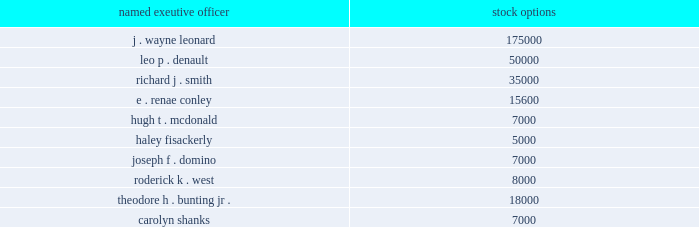For purposes of determining entergy corporation's relative performance for the 2006-2008 period , the committee used the philadelphia utility index as the peer group .
Based on market data and the recommendation of management , the committee compared entergy corporation's total shareholder return against the total shareholder return of the companies that comprised the philadelphia utility index .
Based on a comparison of entergy corporation's performance relative to the philadelphia utility index as described above , the committee concluded that entergy corporation had exceeded the performance targets for the 2006-2008 performance cycle with entergy finishing in the first quartile which resulted in a payment of 250% ( 250 % ) of target ( the maximum amount payable ) .
Each performance unit was then automatically converted into cash at the rate of $ 83.13 per unit , the closing price of entergy corporation common stock on the last trading day of the performance cycle ( december 31 , 2008 ) , plus dividend equivalents accrued over the three-year performance cycle .
See the 2008 option exercises and stock vested table for the amount paid to each of the named executive officers for the 2006-2008 performance unit cycle .
Stock options the personnel committee and in the case of the named executive officers ( other than mr .
Leonard , mr .
Denault and mr .
Smith ) , entergy's chief executive officer and the named executive officer's supervisor consider several factors in determining the amount of stock options it will grant under entergy's equity ownership plans to the named executive officers , including : individual performance ; prevailing market practice in stock option grants ; the targeted long-term value created by the use of stock options ; the number of participants eligible for stock options , and the resulting "burn rate" ( i.e. , the number of stock options authorized divided by the total number of shares outstanding ) to assess the potential dilutive effect ; and the committee's assessment of other elements of compensation provided to the named executive officer for stock option awards to the named executive officers ( other than mr .
Leonard ) , the committee's assessment of individual performance of each named executive officer done in consultation with entergy corporation's chief executive officer is the most important factor in determining the number of options awarded .
The table sets forth the number of stock options granted to each named executive officer in 2008 .
The exercise price for each option was $ 108.20 , which was the closing fair market value of entergy corporation common stock on the date of grant. .
The option grants awarded to the named executive officers ( other than mr .
Leonard and mr .
Lewis ) ranged in amount between 5000 and 50000 shares .
Mr .
Lewis did not receive any stock option awards in 2008 .
In the case of mr .
Leonard , who received 175000 stock options , the committee took special note of his performance as entergy corporation's chief executive officer .
Among other things , the committee noted that .
What is the total value of stock options for leo p . denault , in millions? 
Computations: ((50000 * 108.20) / 1000000)
Answer: 5.41. 